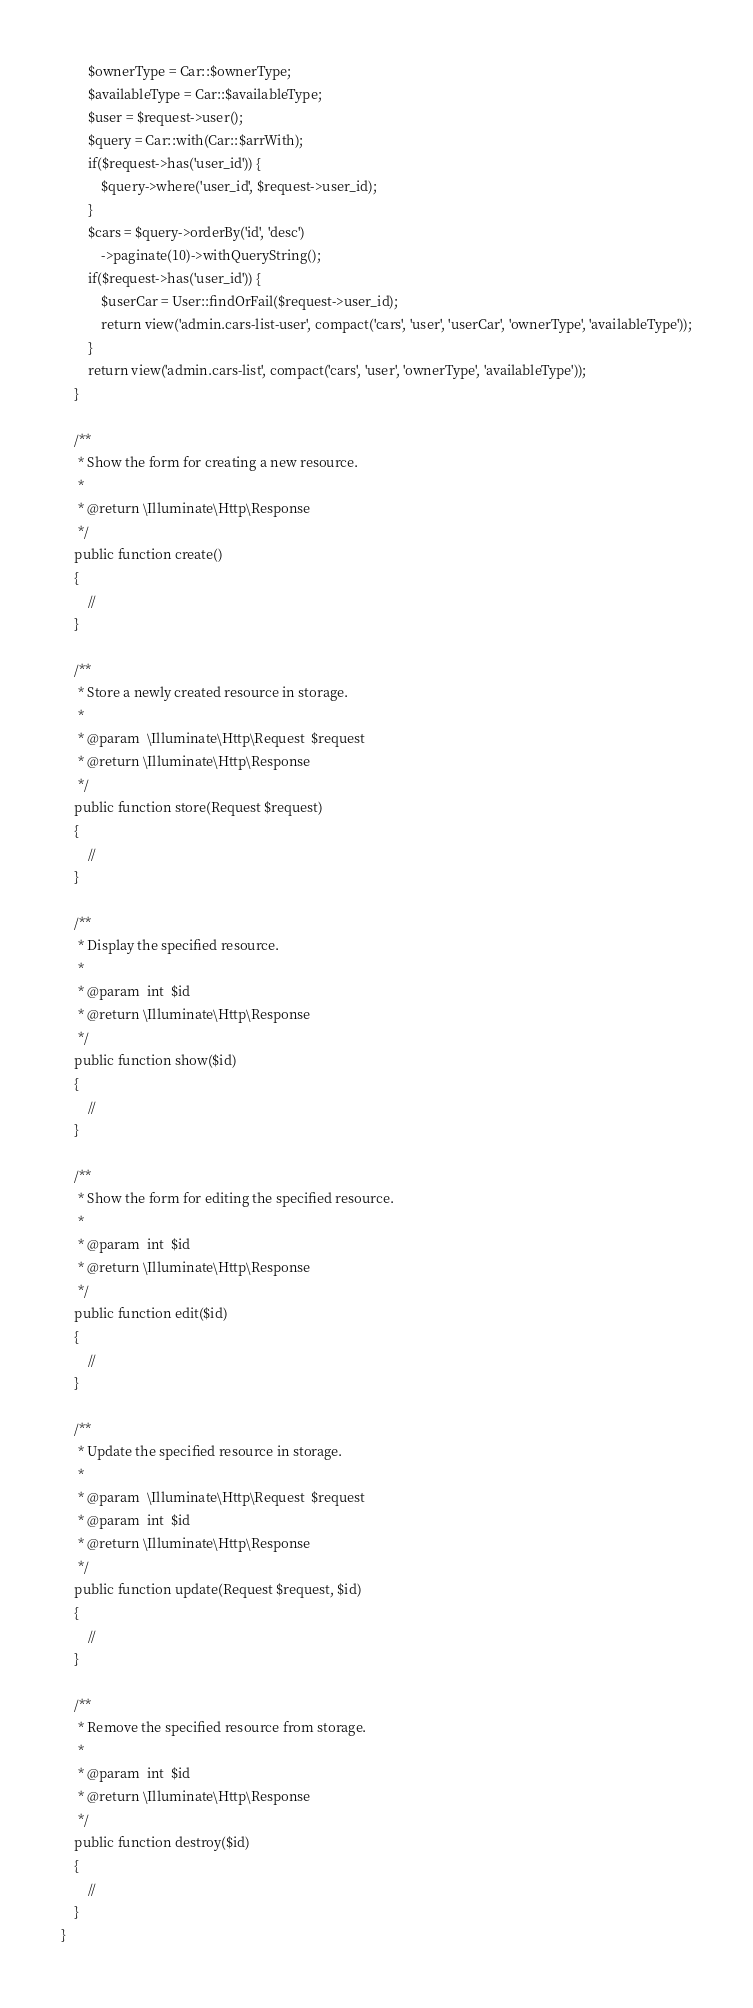<code> <loc_0><loc_0><loc_500><loc_500><_PHP_>        $ownerType = Car::$ownerType;
        $availableType = Car::$availableType;
        $user = $request->user();
        $query = Car::with(Car::$arrWith);
        if($request->has('user_id')) {
            $query->where('user_id', $request->user_id);
        }
        $cars = $query->orderBy('id', 'desc')
            ->paginate(10)->withQueryString();
        if($request->has('user_id')) {
            $userCar = User::findOrFail($request->user_id);
            return view('admin.cars-list-user', compact('cars', 'user', 'userCar', 'ownerType', 'availableType'));
        }
        return view('admin.cars-list', compact('cars', 'user', 'ownerType', 'availableType'));
    }

    /**
     * Show the form for creating a new resource.
     *
     * @return \Illuminate\Http\Response
     */
    public function create()
    {
        //
    }

    /**
     * Store a newly created resource in storage.
     *
     * @param  \Illuminate\Http\Request  $request
     * @return \Illuminate\Http\Response
     */
    public function store(Request $request)
    {
        //
    }

    /**
     * Display the specified resource.
     *
     * @param  int  $id
     * @return \Illuminate\Http\Response
     */
    public function show($id)
    {
        //
    }

    /**
     * Show the form for editing the specified resource.
     *
     * @param  int  $id
     * @return \Illuminate\Http\Response
     */
    public function edit($id)
    {
        //
    }

    /**
     * Update the specified resource in storage.
     *
     * @param  \Illuminate\Http\Request  $request
     * @param  int  $id
     * @return \Illuminate\Http\Response
     */
    public function update(Request $request, $id)
    {
        //
    }

    /**
     * Remove the specified resource from storage.
     *
     * @param  int  $id
     * @return \Illuminate\Http\Response
     */
    public function destroy($id)
    {
        //
    }
}
</code> 